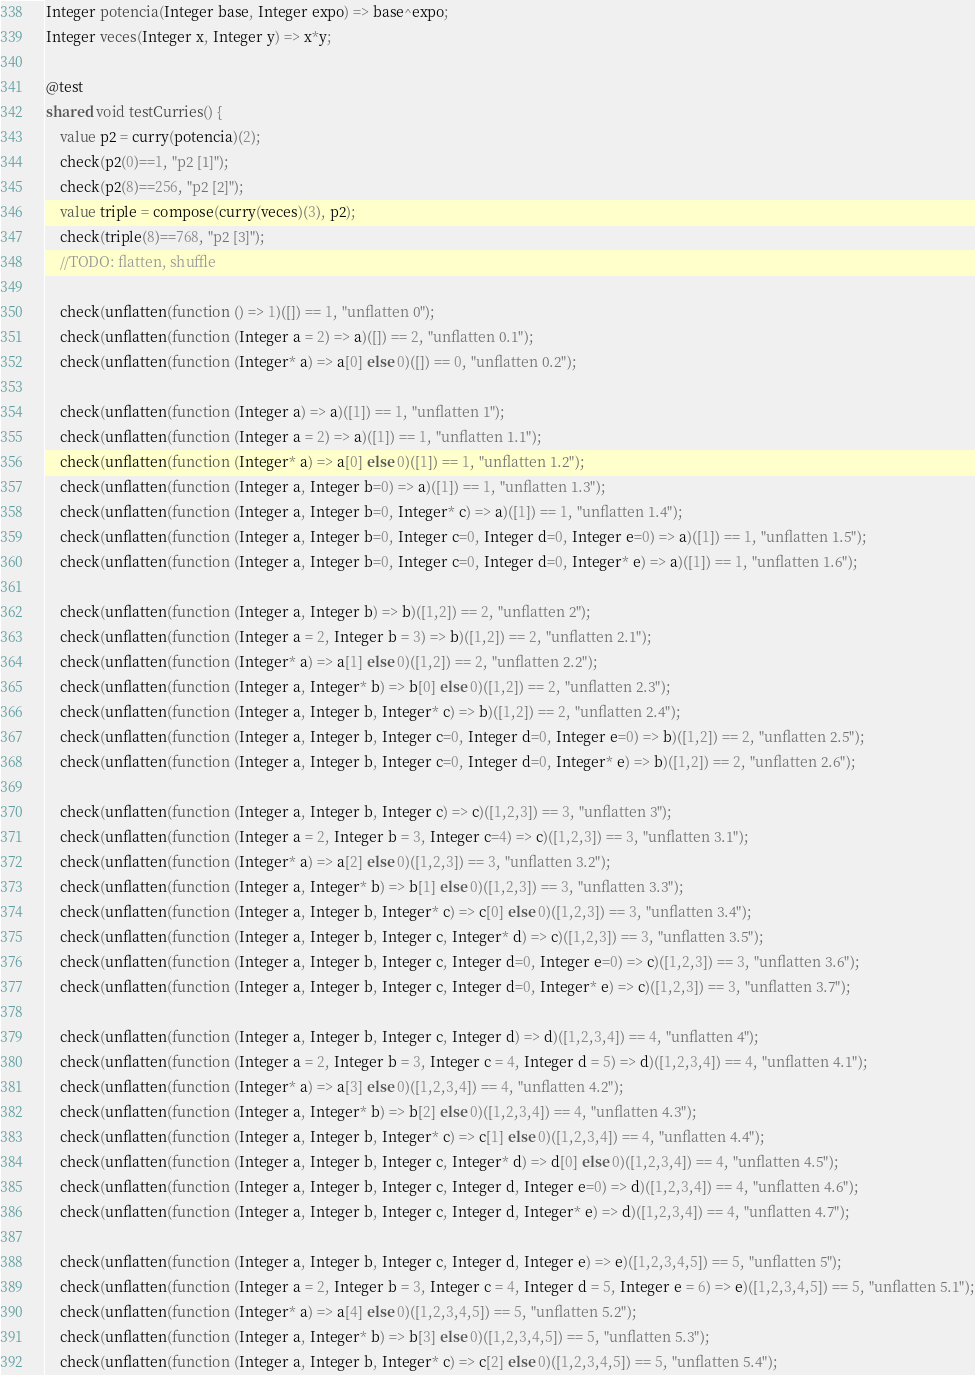Convert code to text. <code><loc_0><loc_0><loc_500><loc_500><_Ceylon_>Integer potencia(Integer base, Integer expo) => base^expo;
Integer veces(Integer x, Integer y) => x*y;

@test
shared void testCurries() {
    value p2 = curry(potencia)(2);
    check(p2(0)==1, "p2 [1]");
    check(p2(8)==256, "p2 [2]");
    value triple = compose(curry(veces)(3), p2);
    check(triple(8)==768, "p2 [3]");
    //TODO: flatten, shuffle
    
    check(unflatten(function () => 1)([]) == 1, "unflatten 0");
    check(unflatten(function (Integer a = 2) => a)([]) == 2, "unflatten 0.1");
    check(unflatten(function (Integer* a) => a[0] else 0)([]) == 0, "unflatten 0.2");
    
    check(unflatten(function (Integer a) => a)([1]) == 1, "unflatten 1");
    check(unflatten(function (Integer a = 2) => a)([1]) == 1, "unflatten 1.1");
    check(unflatten(function (Integer* a) => a[0] else 0)([1]) == 1, "unflatten 1.2");
    check(unflatten(function (Integer a, Integer b=0) => a)([1]) == 1, "unflatten 1.3");
    check(unflatten(function (Integer a, Integer b=0, Integer* c) => a)([1]) == 1, "unflatten 1.4");
    check(unflatten(function (Integer a, Integer b=0, Integer c=0, Integer d=0, Integer e=0) => a)([1]) == 1, "unflatten 1.5");
    check(unflatten(function (Integer a, Integer b=0, Integer c=0, Integer d=0, Integer* e) => a)([1]) == 1, "unflatten 1.6");

    check(unflatten(function (Integer a, Integer b) => b)([1,2]) == 2, "unflatten 2");
    check(unflatten(function (Integer a = 2, Integer b = 3) => b)([1,2]) == 2, "unflatten 2.1");
    check(unflatten(function (Integer* a) => a[1] else 0)([1,2]) == 2, "unflatten 2.2");
    check(unflatten(function (Integer a, Integer* b) => b[0] else 0)([1,2]) == 2, "unflatten 2.3");
    check(unflatten(function (Integer a, Integer b, Integer* c) => b)([1,2]) == 2, "unflatten 2.4");
    check(unflatten(function (Integer a, Integer b, Integer c=0, Integer d=0, Integer e=0) => b)([1,2]) == 2, "unflatten 2.5");
    check(unflatten(function (Integer a, Integer b, Integer c=0, Integer d=0, Integer* e) => b)([1,2]) == 2, "unflatten 2.6");

    check(unflatten(function (Integer a, Integer b, Integer c) => c)([1,2,3]) == 3, "unflatten 3");
    check(unflatten(function (Integer a = 2, Integer b = 3, Integer c=4) => c)([1,2,3]) == 3, "unflatten 3.1");
    check(unflatten(function (Integer* a) => a[2] else 0)([1,2,3]) == 3, "unflatten 3.2");
    check(unflatten(function (Integer a, Integer* b) => b[1] else 0)([1,2,3]) == 3, "unflatten 3.3");
    check(unflatten(function (Integer a, Integer b, Integer* c) => c[0] else 0)([1,2,3]) == 3, "unflatten 3.4");
    check(unflatten(function (Integer a, Integer b, Integer c, Integer* d) => c)([1,2,3]) == 3, "unflatten 3.5");
    check(unflatten(function (Integer a, Integer b, Integer c, Integer d=0, Integer e=0) => c)([1,2,3]) == 3, "unflatten 3.6");
    check(unflatten(function (Integer a, Integer b, Integer c, Integer d=0, Integer* e) => c)([1,2,3]) == 3, "unflatten 3.7");

    check(unflatten(function (Integer a, Integer b, Integer c, Integer d) => d)([1,2,3,4]) == 4, "unflatten 4");
    check(unflatten(function (Integer a = 2, Integer b = 3, Integer c = 4, Integer d = 5) => d)([1,2,3,4]) == 4, "unflatten 4.1");
    check(unflatten(function (Integer* a) => a[3] else 0)([1,2,3,4]) == 4, "unflatten 4.2");
    check(unflatten(function (Integer a, Integer* b) => b[2] else 0)([1,2,3,4]) == 4, "unflatten 4.3");
    check(unflatten(function (Integer a, Integer b, Integer* c) => c[1] else 0)([1,2,3,4]) == 4, "unflatten 4.4");
    check(unflatten(function (Integer a, Integer b, Integer c, Integer* d) => d[0] else 0)([1,2,3,4]) == 4, "unflatten 4.5");
    check(unflatten(function (Integer a, Integer b, Integer c, Integer d, Integer e=0) => d)([1,2,3,4]) == 4, "unflatten 4.6");
    check(unflatten(function (Integer a, Integer b, Integer c, Integer d, Integer* e) => d)([1,2,3,4]) == 4, "unflatten 4.7");

    check(unflatten(function (Integer a, Integer b, Integer c, Integer d, Integer e) => e)([1,2,3,4,5]) == 5, "unflatten 5");
    check(unflatten(function (Integer a = 2, Integer b = 3, Integer c = 4, Integer d = 5, Integer e = 6) => e)([1,2,3,4,5]) == 5, "unflatten 5.1");
    check(unflatten(function (Integer* a) => a[4] else 0)([1,2,3,4,5]) == 5, "unflatten 5.2");
    check(unflatten(function (Integer a, Integer* b) => b[3] else 0)([1,2,3,4,5]) == 5, "unflatten 5.3");
    check(unflatten(function (Integer a, Integer b, Integer* c) => c[2] else 0)([1,2,3,4,5]) == 5, "unflatten 5.4");</code> 